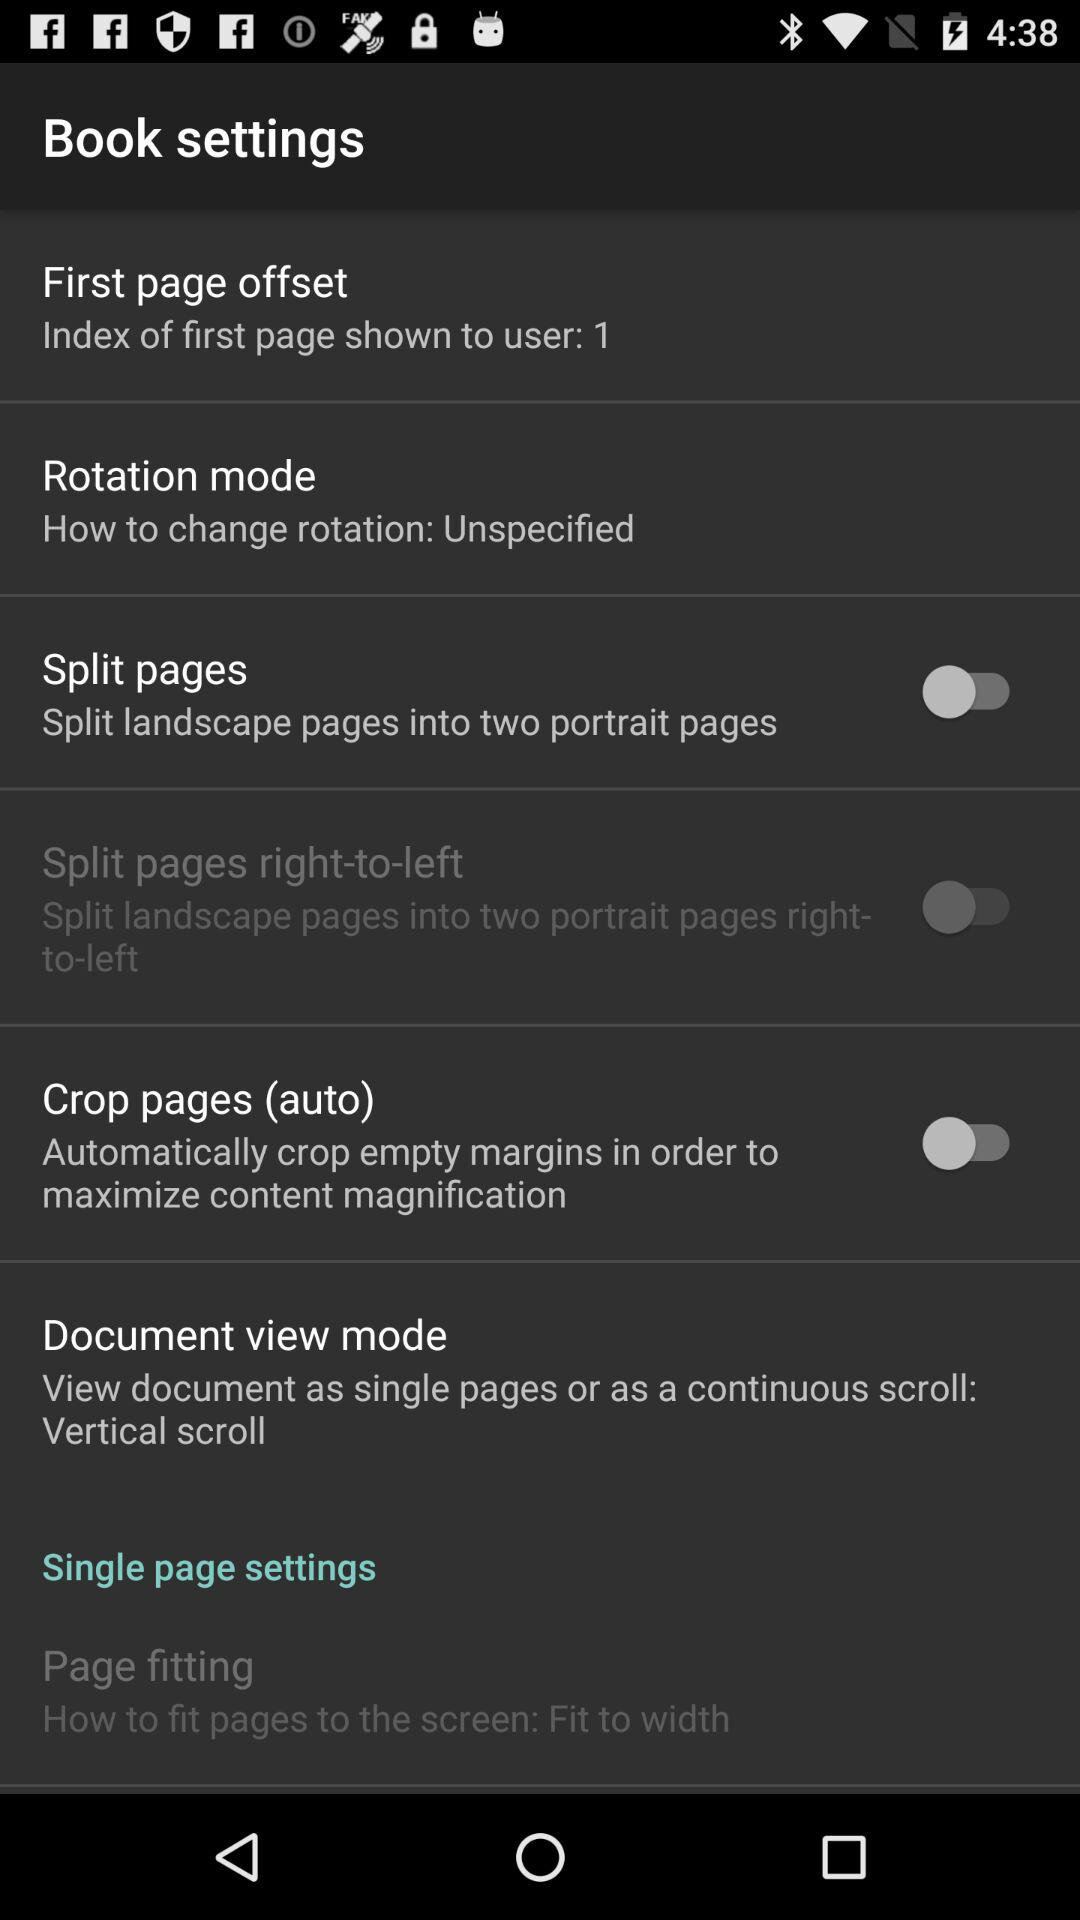What is the status of "Split pages"? The status of "Split pages" is "off". 